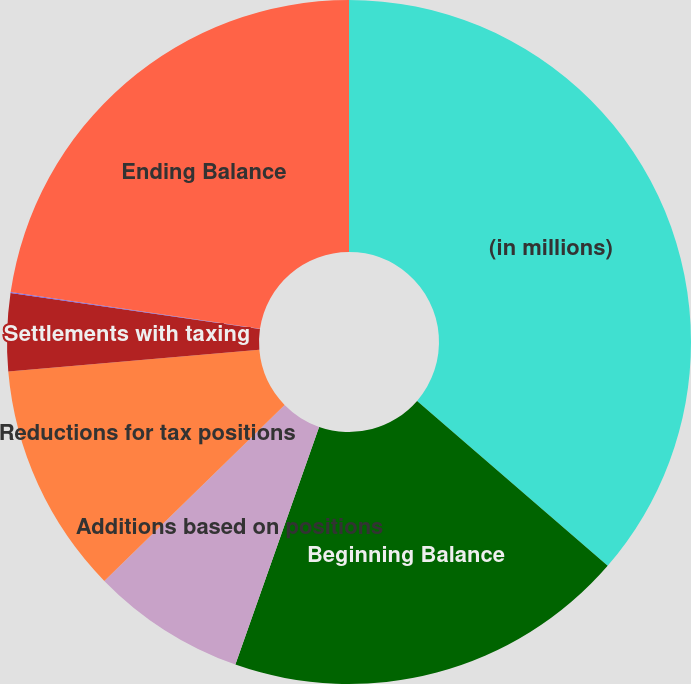<chart> <loc_0><loc_0><loc_500><loc_500><pie_chart><fcel>(in millions)<fcel>Beginning Balance<fcel>Additions based on positions<fcel>Reductions for tax positions<fcel>Settlements with taxing<fcel>Statute of limitation<fcel>Ending Balance<nl><fcel>36.35%<fcel>19.04%<fcel>7.3%<fcel>10.93%<fcel>3.67%<fcel>0.04%<fcel>22.67%<nl></chart> 